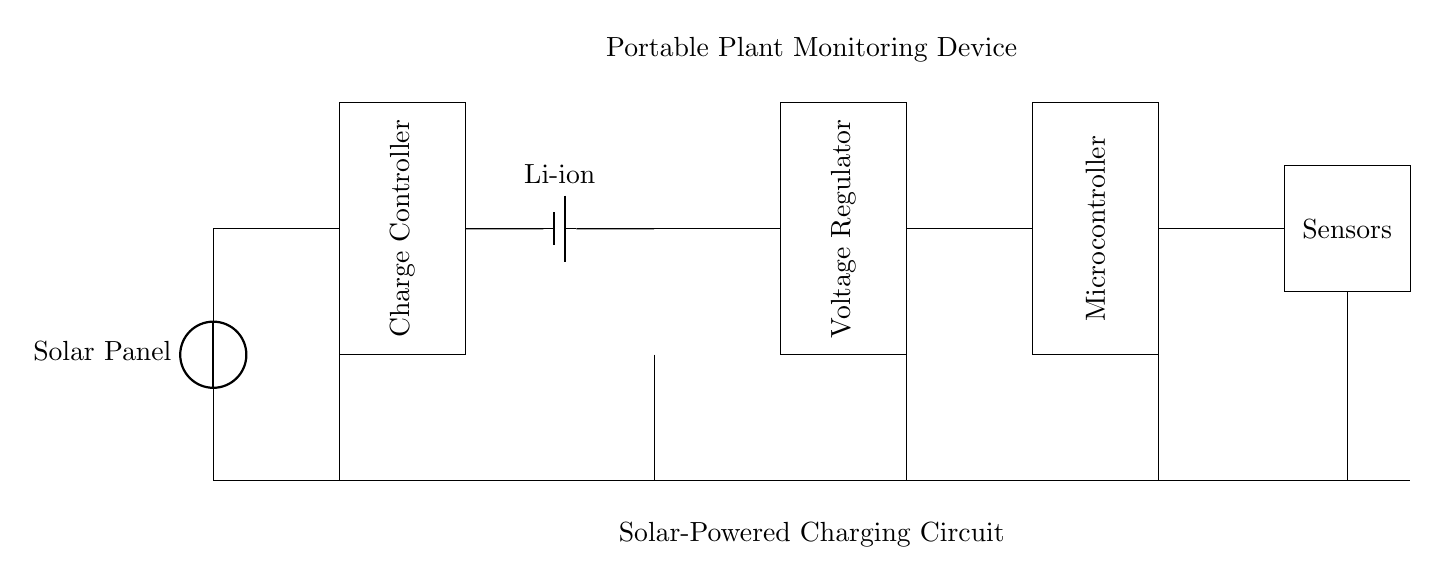What is the main power source for the circuit? The circuit is powered primarily by the solar panel, which converts sunlight into electrical energy. There are no other major power sources indicated in the diagram.
Answer: Solar Panel What type of battery is used? The circuit diagram specifies a Li-ion battery, which is a common type of rechargeable battery known for its high energy density.
Answer: Li-ion How many components are directly connected to the battery? The battery is directly connected to the charge controller and the voltage regulator, which are the immediate components in the path of the electric flow.
Answer: Two What component regulates the output voltage? The voltage regulator is the component in this circuit responsible for managing and stabilizing the output voltage from the battery before it is supplied to the microcontroller and sensors.
Answer: Voltage Regulator What type of controller is in this circuit? The circuit features a microcontroller, which is essential for processing input from the sensors and controlling the operation of the plant monitoring device.
Answer: Microcontroller Which component connects the solar panel voltage to the battery? The charge controller connects the voltage generated by the solar panel to the battery, controlling the flow of current to ensure safe charging and prevent overcharging.
Answer: Charge Controller What do the sensors in this circuit monitor? The sensors are designed to monitor various environmental conditions pertinent to plants, such as moisture or humidity levels, which are crucial for effective plant care.
Answer: Sensors 